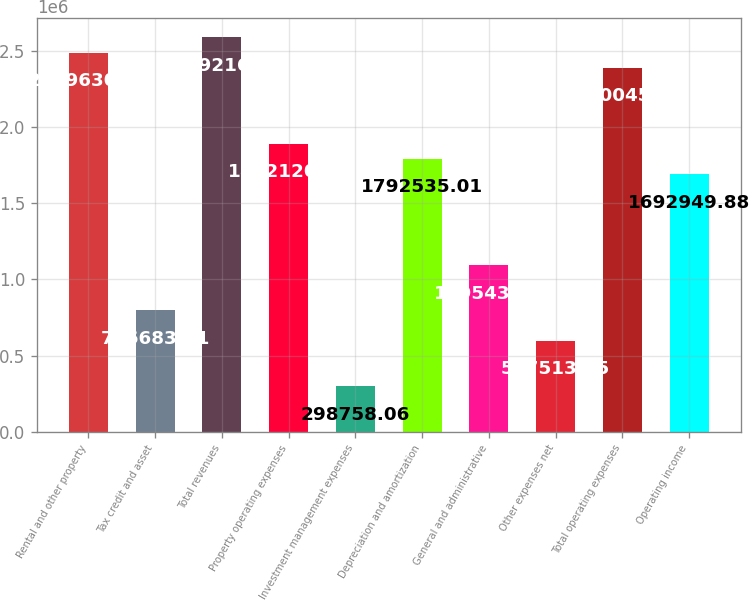Convert chart to OTSL. <chart><loc_0><loc_0><loc_500><loc_500><bar_chart><fcel>Rental and other property<fcel>Tax credit and asset<fcel>Total revenues<fcel>Property operating expenses<fcel>Investment management expenses<fcel>Depreciation and amortization<fcel>General and administrative<fcel>Other expenses net<fcel>Total operating expenses<fcel>Operating income<nl><fcel>2.48963e+06<fcel>796684<fcel>2.58922e+06<fcel>1.89212e+06<fcel>298758<fcel>1.79254e+06<fcel>1.09544e+06<fcel>597513<fcel>2.39005e+06<fcel>1.69295e+06<nl></chart> 